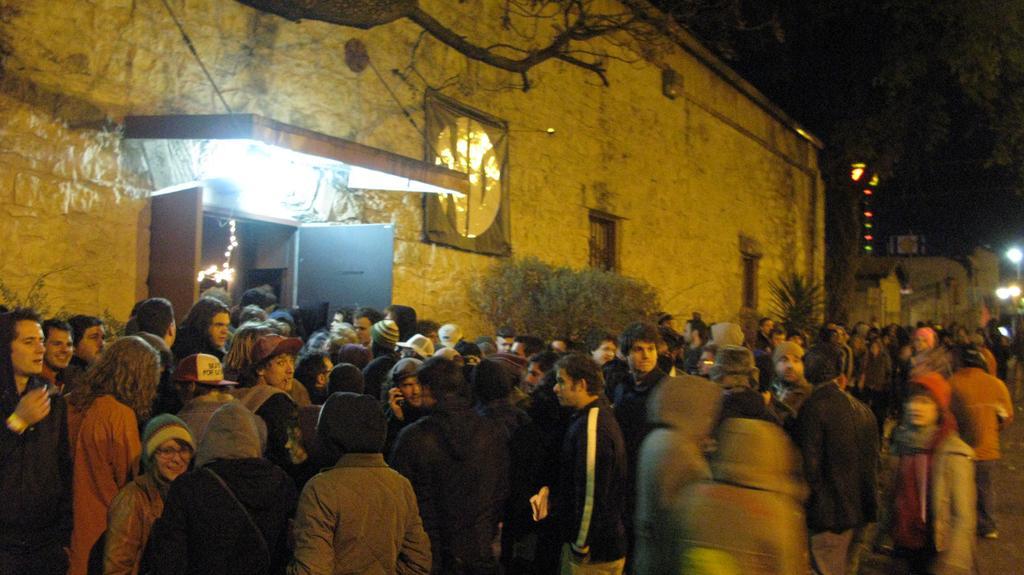Can you describe this image briefly? In the image in the center we can see a group of people are standing and few people are wearing hat. In the background there is a building,wall,door,lights,windows,trees etc. 